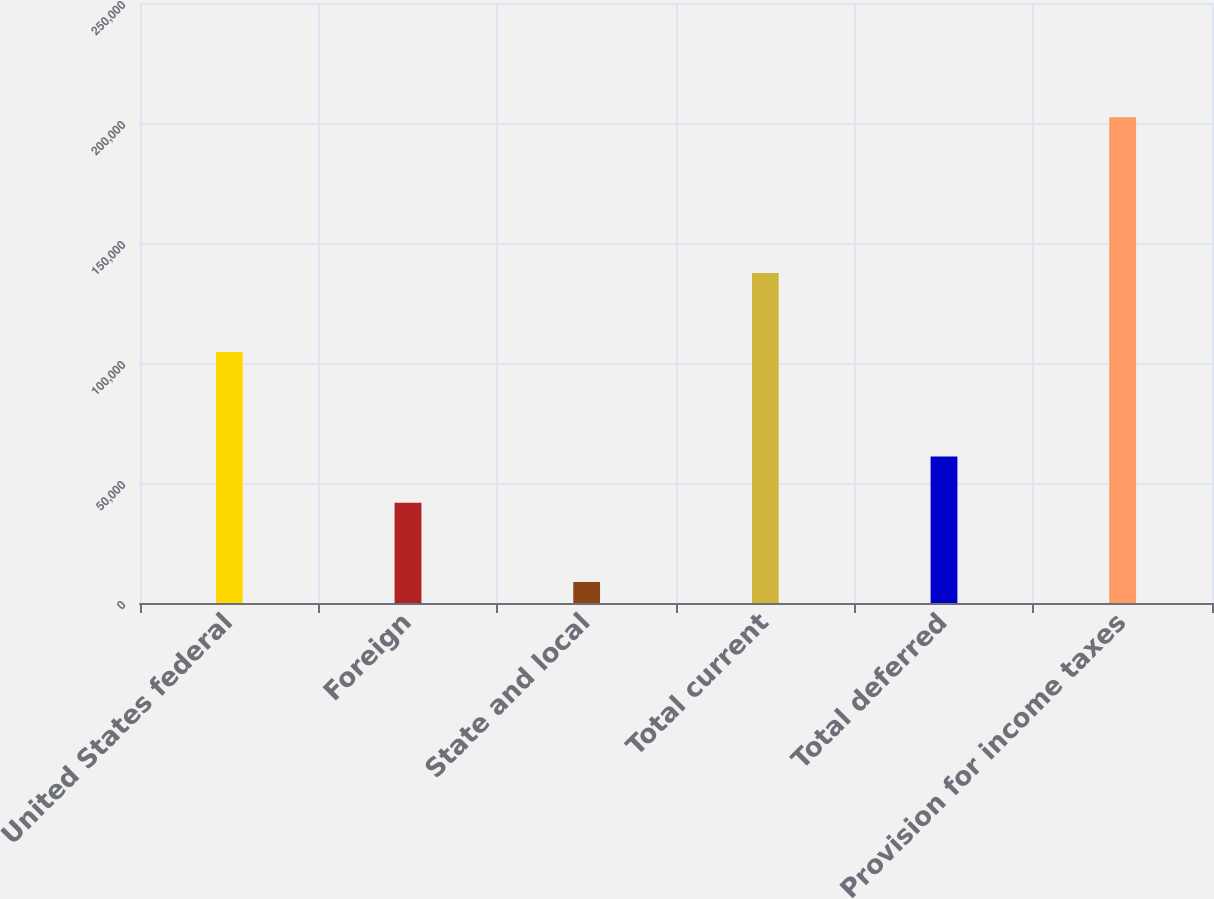Convert chart. <chart><loc_0><loc_0><loc_500><loc_500><bar_chart><fcel>United States federal<fcel>Foreign<fcel>State and local<fcel>Total current<fcel>Total deferred<fcel>Provision for income taxes<nl><fcel>104587<fcel>41724<fcel>8769<fcel>137542<fcel>61085.4<fcel>202383<nl></chart> 